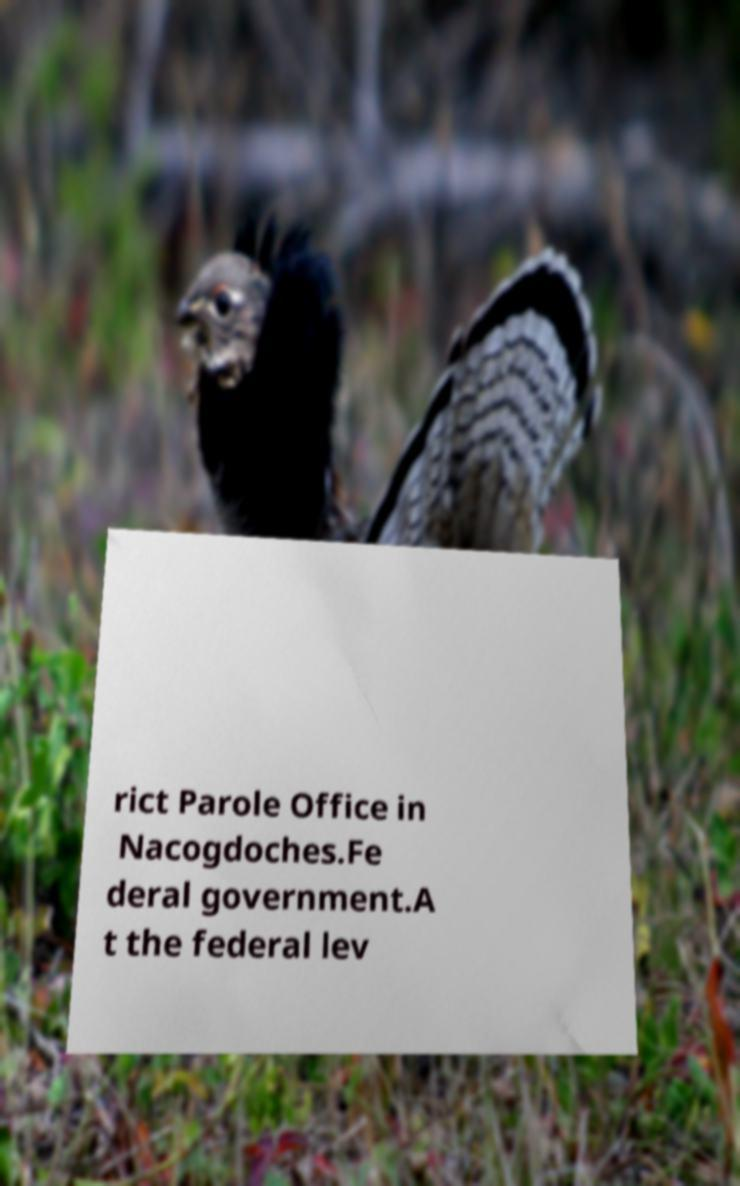For documentation purposes, I need the text within this image transcribed. Could you provide that? rict Parole Office in Nacogdoches.Fe deral government.A t the federal lev 